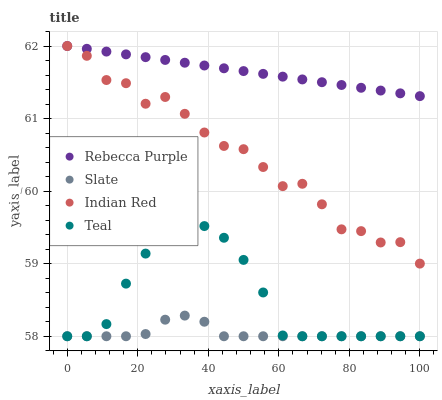Does Slate have the minimum area under the curve?
Answer yes or no. Yes. Does Rebecca Purple have the maximum area under the curve?
Answer yes or no. Yes. Does Rebecca Purple have the minimum area under the curve?
Answer yes or no. No. Does Slate have the maximum area under the curve?
Answer yes or no. No. Is Rebecca Purple the smoothest?
Answer yes or no. Yes. Is Indian Red the roughest?
Answer yes or no. Yes. Is Slate the smoothest?
Answer yes or no. No. Is Slate the roughest?
Answer yes or no. No. Does Teal have the lowest value?
Answer yes or no. Yes. Does Rebecca Purple have the lowest value?
Answer yes or no. No. Does Indian Red have the highest value?
Answer yes or no. Yes. Does Slate have the highest value?
Answer yes or no. No. Is Teal less than Rebecca Purple?
Answer yes or no. Yes. Is Rebecca Purple greater than Slate?
Answer yes or no. Yes. Does Teal intersect Slate?
Answer yes or no. Yes. Is Teal less than Slate?
Answer yes or no. No. Is Teal greater than Slate?
Answer yes or no. No. Does Teal intersect Rebecca Purple?
Answer yes or no. No. 